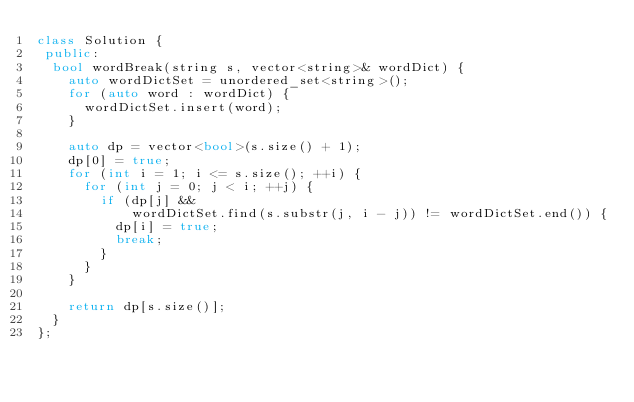<code> <loc_0><loc_0><loc_500><loc_500><_C++_>class Solution {
 public:
  bool wordBreak(string s, vector<string>& wordDict) {
    auto wordDictSet = unordered_set<string>();
    for (auto word : wordDict) {
      wordDictSet.insert(word);
    }

    auto dp = vector<bool>(s.size() + 1);
    dp[0] = true;
    for (int i = 1; i <= s.size(); ++i) {
      for (int j = 0; j < i; ++j) {
        if (dp[j] &&
            wordDictSet.find(s.substr(j, i - j)) != wordDictSet.end()) {
          dp[i] = true;
          break;
        }
      }
    }

    return dp[s.size()];
  }
};</code> 